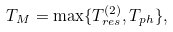Convert formula to latex. <formula><loc_0><loc_0><loc_500><loc_500>T _ { M } = \max \{ T ^ { ( 2 ) } _ { r e s } , T _ { p h } \} ,</formula> 